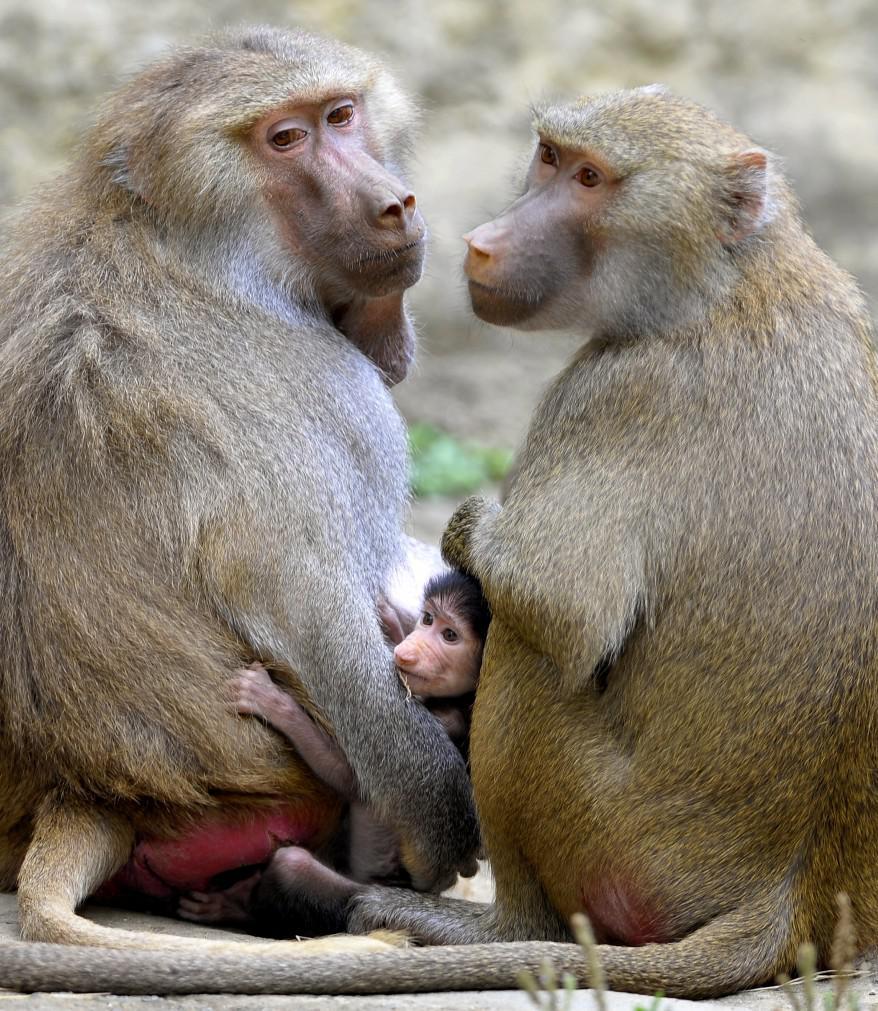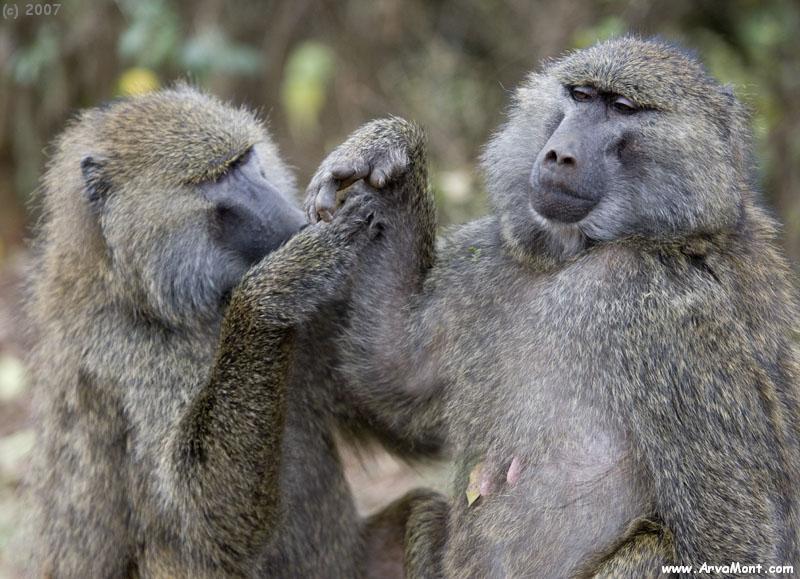The first image is the image on the left, the second image is the image on the right. Assess this claim about the two images: "An image shows two sitting adult monkeys, plus a smaller monkey in the middle of the scene.". Correct or not? Answer yes or no. Yes. 